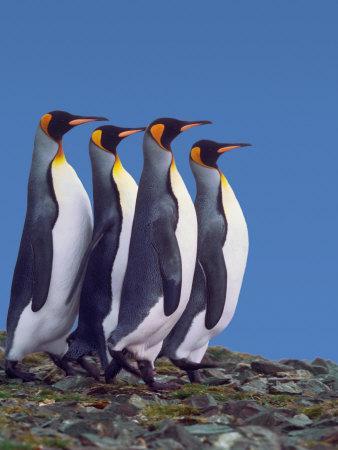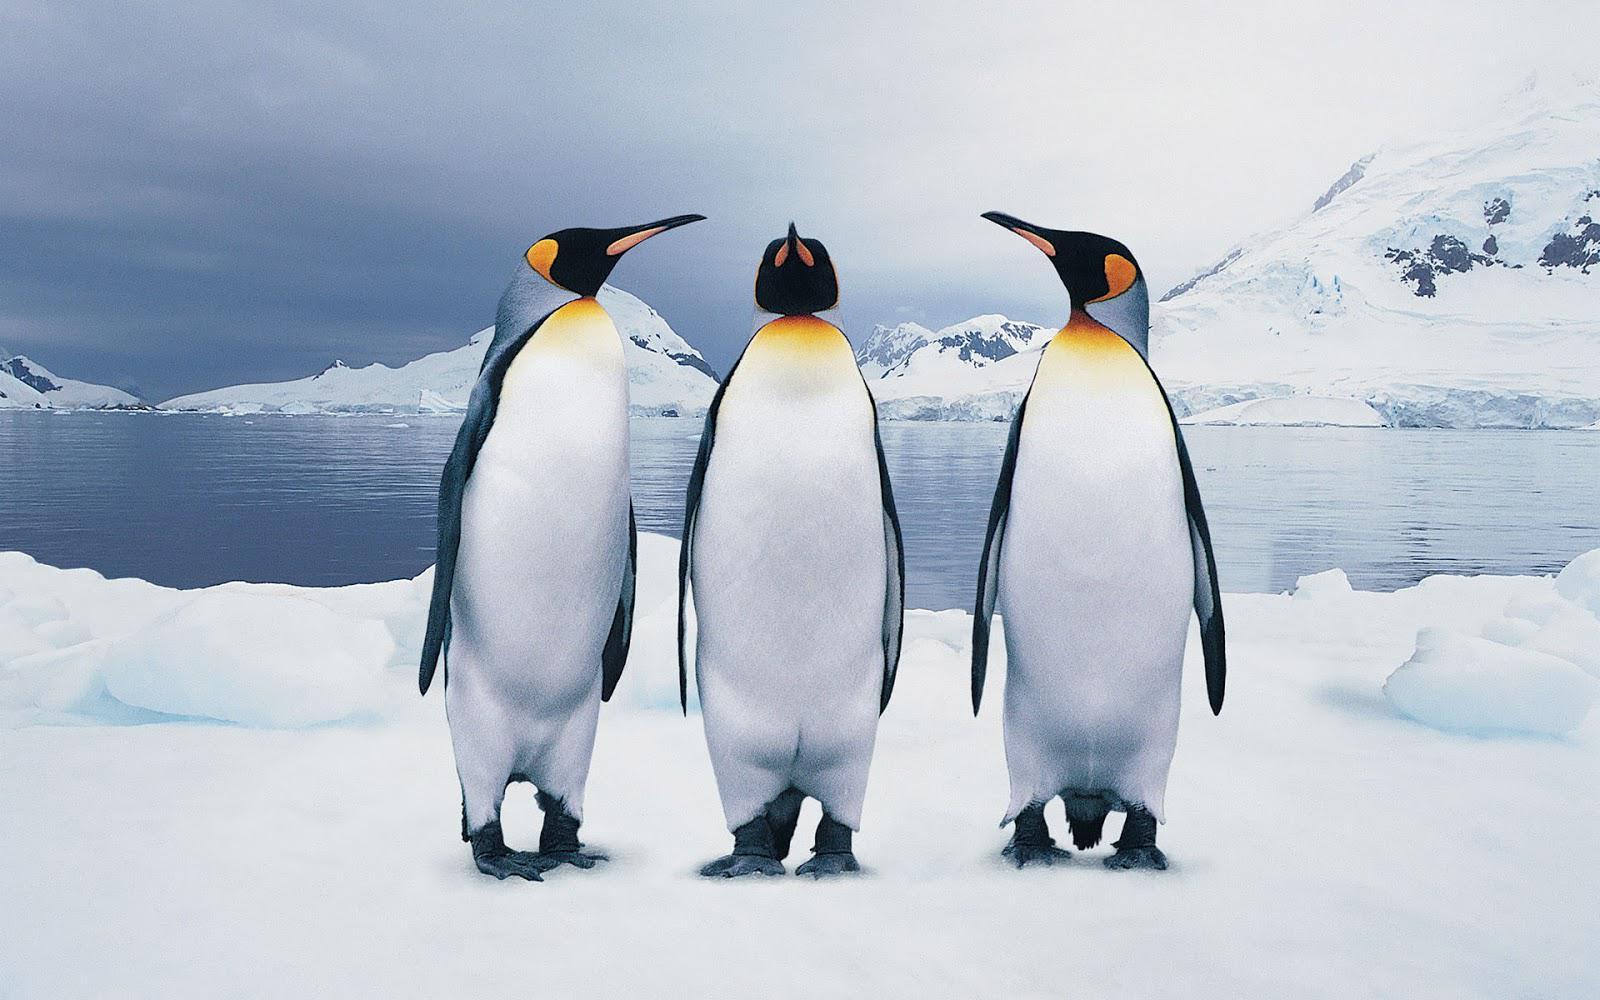The first image is the image on the left, the second image is the image on the right. Considering the images on both sides, is "There are exactly two penguins." valid? Answer yes or no. No. 